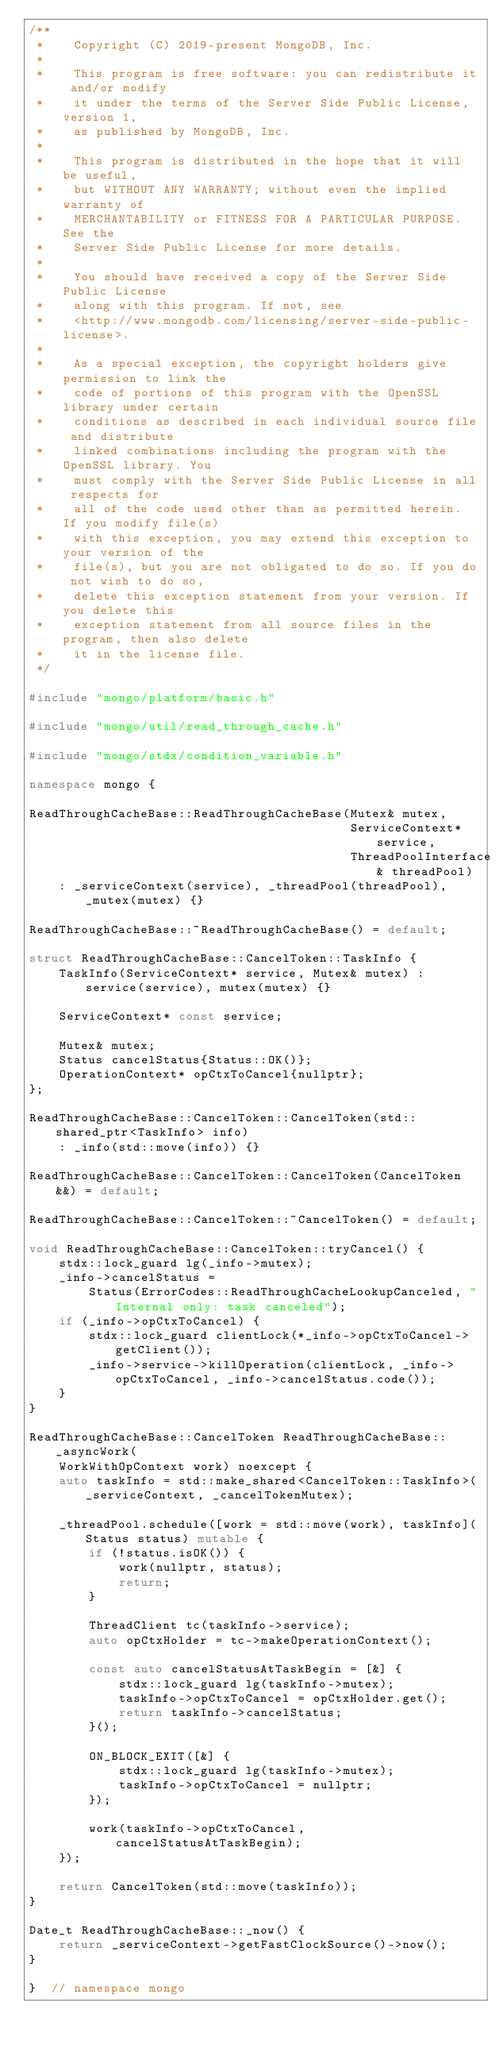Convert code to text. <code><loc_0><loc_0><loc_500><loc_500><_C++_>/**
 *    Copyright (C) 2019-present MongoDB, Inc.
 *
 *    This program is free software: you can redistribute it and/or modify
 *    it under the terms of the Server Side Public License, version 1,
 *    as published by MongoDB, Inc.
 *
 *    This program is distributed in the hope that it will be useful,
 *    but WITHOUT ANY WARRANTY; without even the implied warranty of
 *    MERCHANTABILITY or FITNESS FOR A PARTICULAR PURPOSE.  See the
 *    Server Side Public License for more details.
 *
 *    You should have received a copy of the Server Side Public License
 *    along with this program. If not, see
 *    <http://www.mongodb.com/licensing/server-side-public-license>.
 *
 *    As a special exception, the copyright holders give permission to link the
 *    code of portions of this program with the OpenSSL library under certain
 *    conditions as described in each individual source file and distribute
 *    linked combinations including the program with the OpenSSL library. You
 *    must comply with the Server Side Public License in all respects for
 *    all of the code used other than as permitted herein. If you modify file(s)
 *    with this exception, you may extend this exception to your version of the
 *    file(s), but you are not obligated to do so. If you do not wish to do so,
 *    delete this exception statement from your version. If you delete this
 *    exception statement from all source files in the program, then also delete
 *    it in the license file.
 */

#include "mongo/platform/basic.h"

#include "mongo/util/read_through_cache.h"

#include "mongo/stdx/condition_variable.h"

namespace mongo {

ReadThroughCacheBase::ReadThroughCacheBase(Mutex& mutex,
                                           ServiceContext* service,
                                           ThreadPoolInterface& threadPool)
    : _serviceContext(service), _threadPool(threadPool), _mutex(mutex) {}

ReadThroughCacheBase::~ReadThroughCacheBase() = default;

struct ReadThroughCacheBase::CancelToken::TaskInfo {
    TaskInfo(ServiceContext* service, Mutex& mutex) : service(service), mutex(mutex) {}

    ServiceContext* const service;

    Mutex& mutex;
    Status cancelStatus{Status::OK()};
    OperationContext* opCtxToCancel{nullptr};
};

ReadThroughCacheBase::CancelToken::CancelToken(std::shared_ptr<TaskInfo> info)
    : _info(std::move(info)) {}

ReadThroughCacheBase::CancelToken::CancelToken(CancelToken&&) = default;

ReadThroughCacheBase::CancelToken::~CancelToken() = default;

void ReadThroughCacheBase::CancelToken::tryCancel() {
    stdx::lock_guard lg(_info->mutex);
    _info->cancelStatus =
        Status(ErrorCodes::ReadThroughCacheLookupCanceled, "Internal only: task canceled");
    if (_info->opCtxToCancel) {
        stdx::lock_guard clientLock(*_info->opCtxToCancel->getClient());
        _info->service->killOperation(clientLock, _info->opCtxToCancel, _info->cancelStatus.code());
    }
}

ReadThroughCacheBase::CancelToken ReadThroughCacheBase::_asyncWork(
    WorkWithOpContext work) noexcept {
    auto taskInfo = std::make_shared<CancelToken::TaskInfo>(_serviceContext, _cancelTokenMutex);

    _threadPool.schedule([work = std::move(work), taskInfo](Status status) mutable {
        if (!status.isOK()) {
            work(nullptr, status);
            return;
        }

        ThreadClient tc(taskInfo->service);
        auto opCtxHolder = tc->makeOperationContext();

        const auto cancelStatusAtTaskBegin = [&] {
            stdx::lock_guard lg(taskInfo->mutex);
            taskInfo->opCtxToCancel = opCtxHolder.get();
            return taskInfo->cancelStatus;
        }();

        ON_BLOCK_EXIT([&] {
            stdx::lock_guard lg(taskInfo->mutex);
            taskInfo->opCtxToCancel = nullptr;
        });

        work(taskInfo->opCtxToCancel, cancelStatusAtTaskBegin);
    });

    return CancelToken(std::move(taskInfo));
}

Date_t ReadThroughCacheBase::_now() {
    return _serviceContext->getFastClockSource()->now();
}

}  // namespace mongo
</code> 